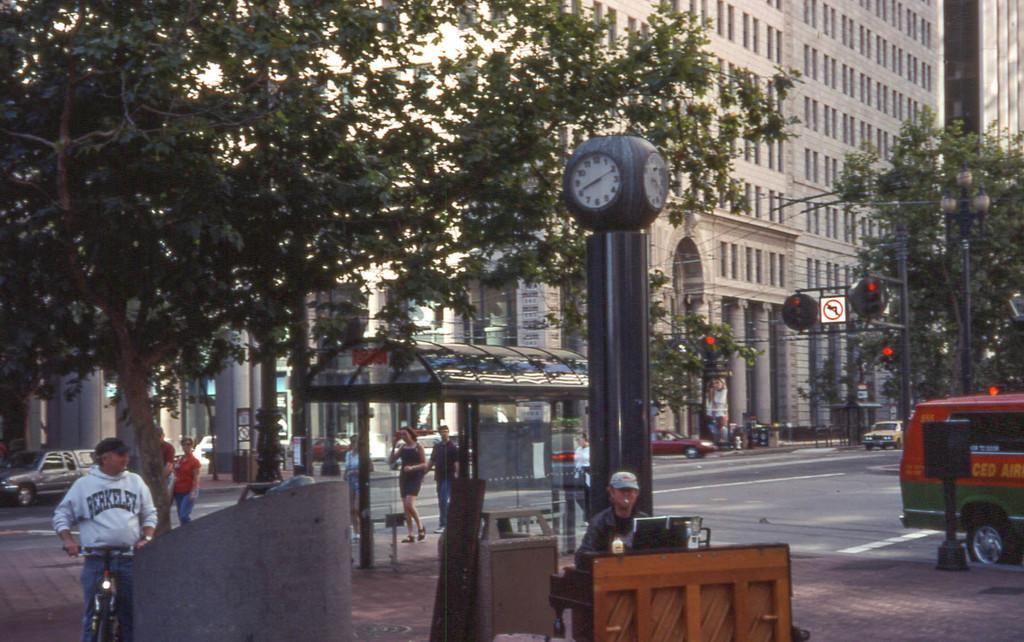How would you summarize this image in a sentence or two? In the picture I can see a person standing in between a bicycle in the left corner and there is another person sitting and there is a table in front of him and there is a vehicle in the right corner and there are few persons,trees,buildings and traffic signals in the background. 